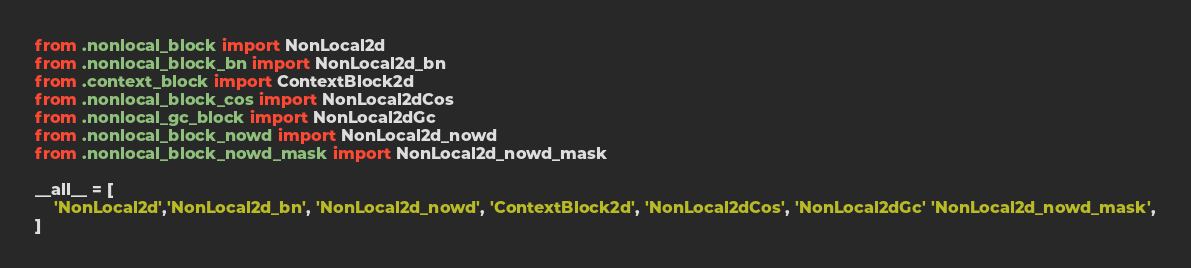<code> <loc_0><loc_0><loc_500><loc_500><_Python_>from .nonlocal_block import NonLocal2d
from .nonlocal_block_bn import NonLocal2d_bn
from .context_block import ContextBlock2d
from .nonlocal_block_cos import NonLocal2dCos
from .nonlocal_gc_block import NonLocal2dGc
from .nonlocal_block_nowd import NonLocal2d_nowd
from .nonlocal_block_nowd_mask import NonLocal2d_nowd_mask

__all__ = [
    'NonLocal2d','NonLocal2d_bn', 'NonLocal2d_nowd', 'ContextBlock2d', 'NonLocal2dCos', 'NonLocal2dGc' 'NonLocal2d_nowd_mask',
]
</code> 